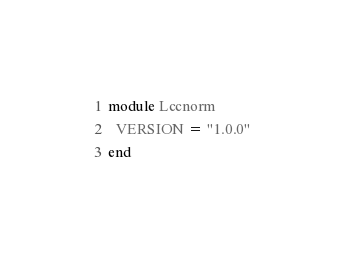<code> <loc_0><loc_0><loc_500><loc_500><_Ruby_>module Lccnorm
  VERSION = "1.0.0"
end
</code> 